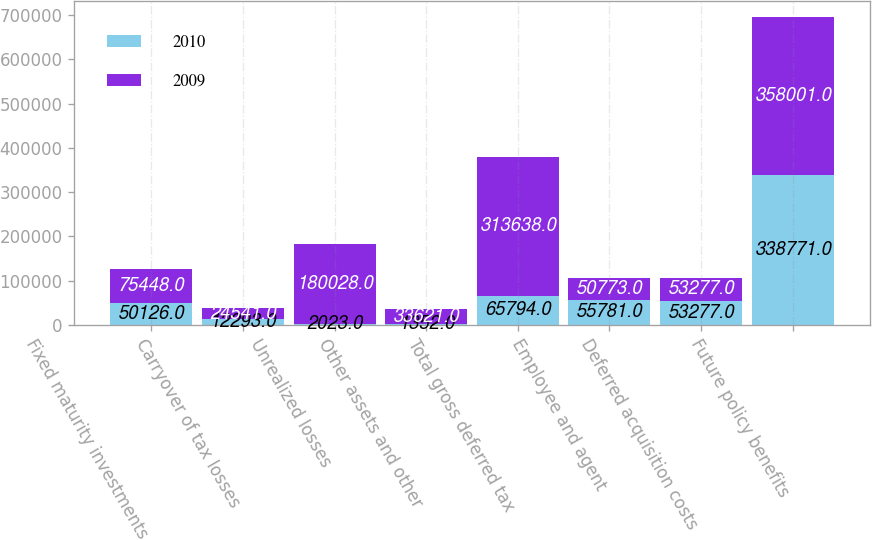<chart> <loc_0><loc_0><loc_500><loc_500><stacked_bar_chart><ecel><fcel>Fixed maturity investments<fcel>Carryover of tax losses<fcel>Unrealized losses<fcel>Other assets and other<fcel>Total gross deferred tax<fcel>Employee and agent<fcel>Deferred acquisition costs<fcel>Future policy benefits<nl><fcel>2010<fcel>50126<fcel>12293<fcel>2023<fcel>1352<fcel>65794<fcel>55781<fcel>53277<fcel>338771<nl><fcel>2009<fcel>75448<fcel>24541<fcel>180028<fcel>33621<fcel>313638<fcel>50773<fcel>53277<fcel>358001<nl></chart> 